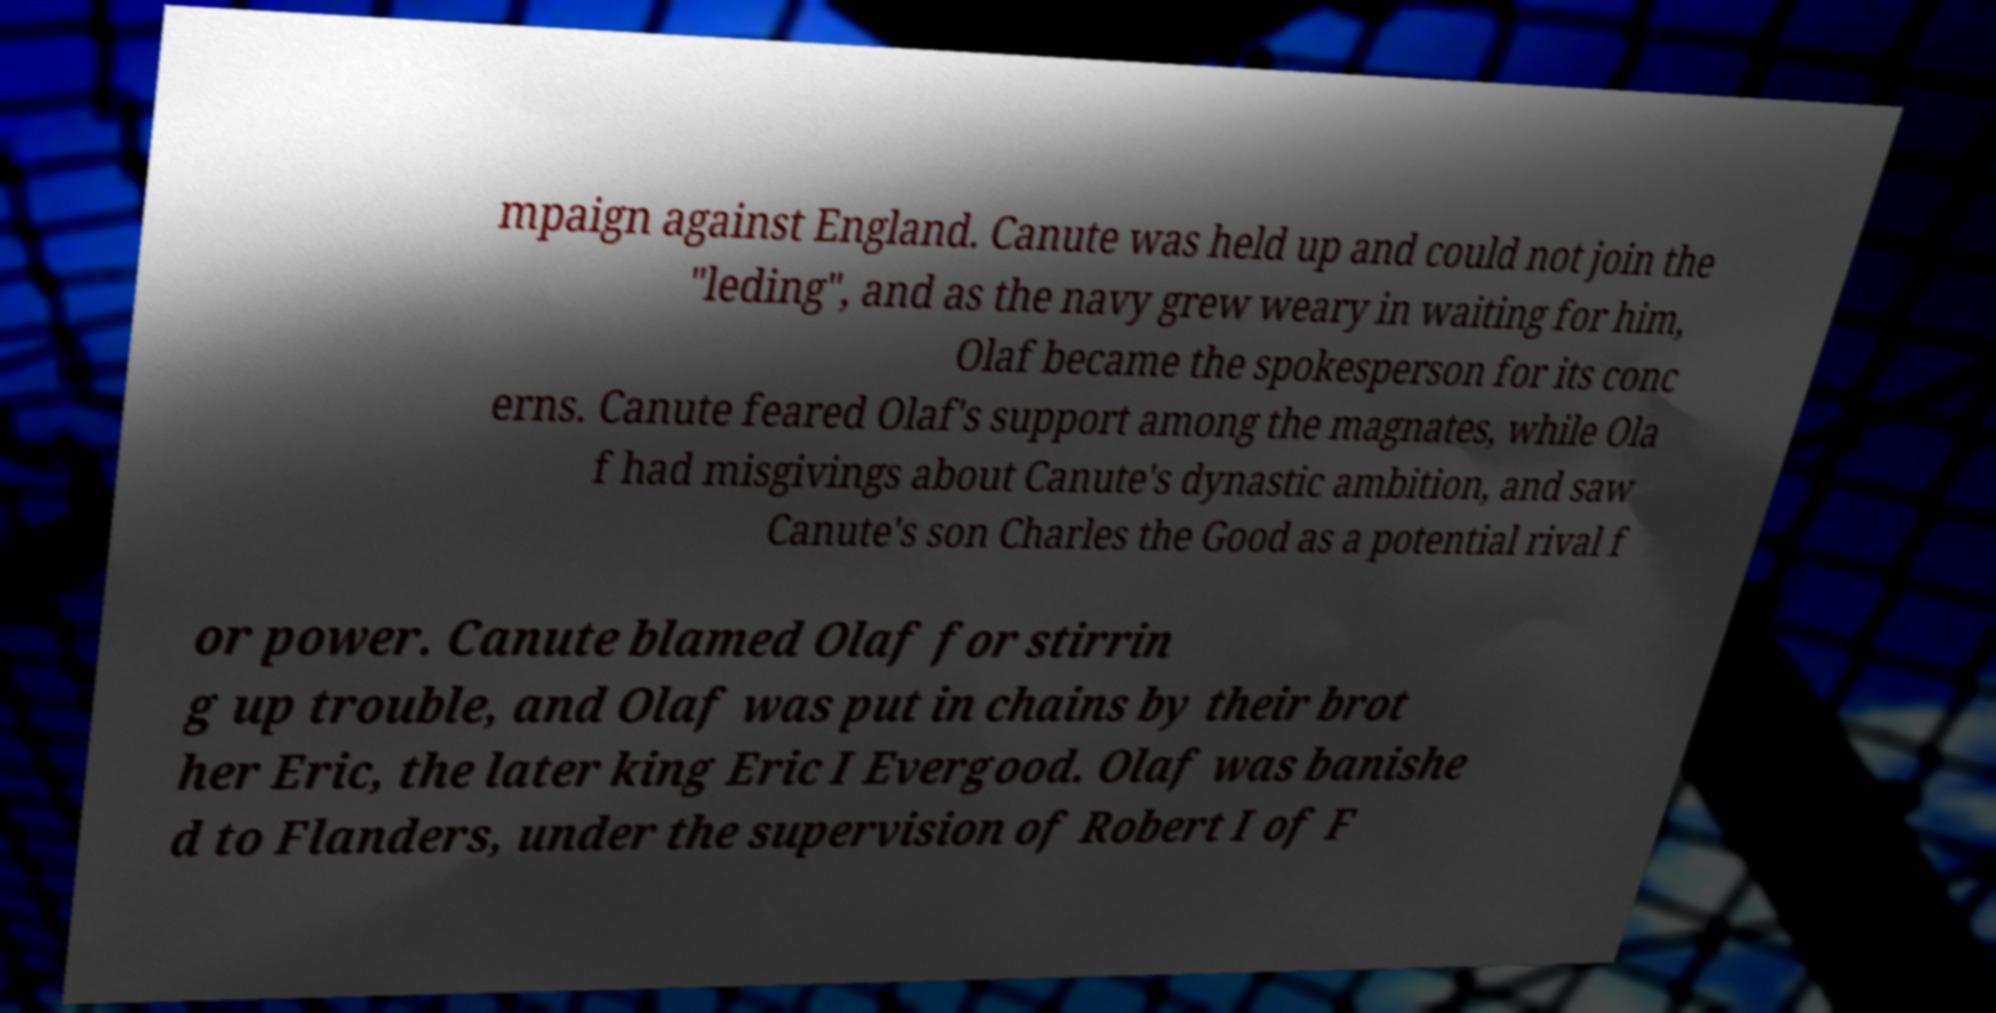Please identify and transcribe the text found in this image. mpaign against England. Canute was held up and could not join the "leding", and as the navy grew weary in waiting for him, Olaf became the spokesperson for its conc erns. Canute feared Olaf's support among the magnates, while Ola f had misgivings about Canute's dynastic ambition, and saw Canute's son Charles the Good as a potential rival f or power. Canute blamed Olaf for stirrin g up trouble, and Olaf was put in chains by their brot her Eric, the later king Eric I Evergood. Olaf was banishe d to Flanders, under the supervision of Robert I of F 